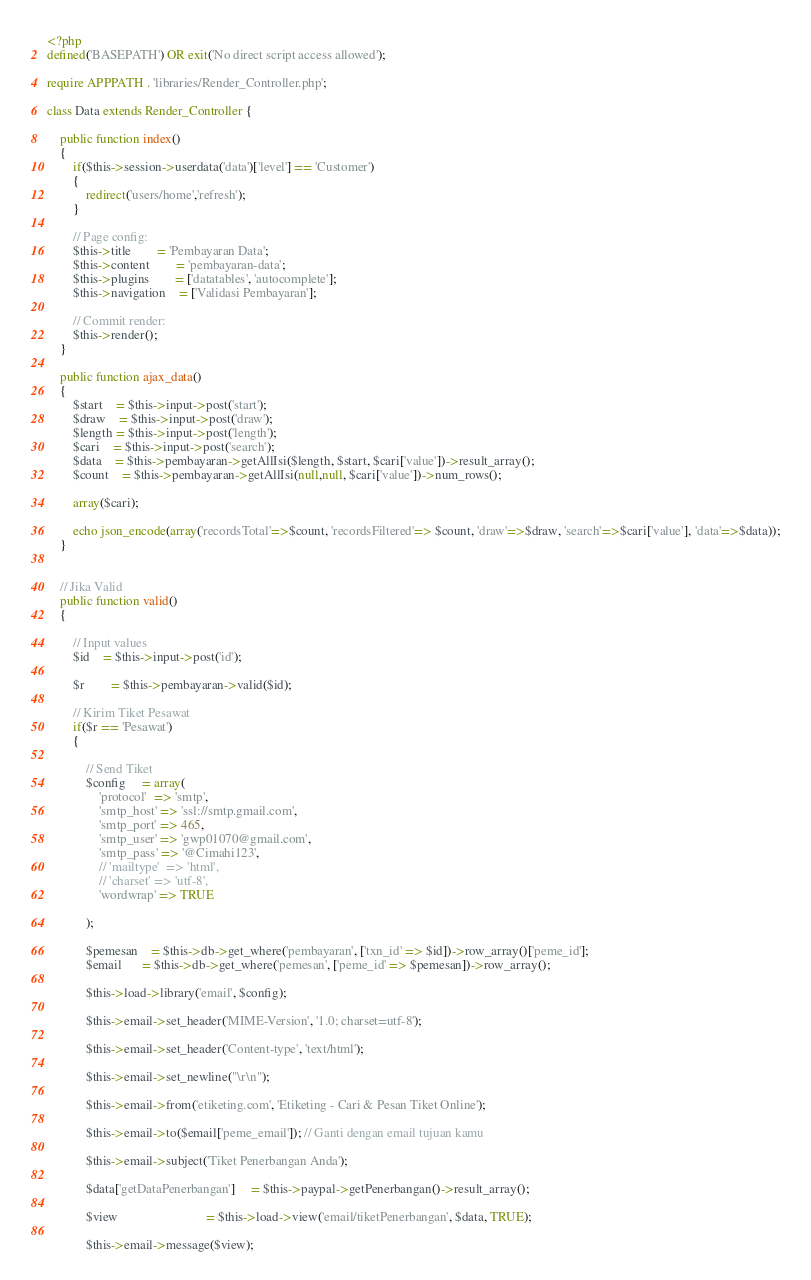Convert code to text. <code><loc_0><loc_0><loc_500><loc_500><_PHP_><?php
defined('BASEPATH') OR exit('No direct script access allowed');

require APPPATH . 'libraries/Render_Controller.php';

class Data extends Render_Controller {

	public function index() 
	{
		if($this->session->userdata('data')['level'] == 'Customer')
		{
			redirect('users/home','refresh');
		}

		// Page config:
		$this->title 		= 'Pembayaran Data';
		$this->content 		= 'pembayaran-data'; 
		$this->plugins 		= ['datatables', 'autocomplete'];
		$this->navigation 	= ['Validasi Pembayaran'];

		// Commit render:
		$this->render();
	}

	public function ajax_data()
	{
		$start 	= $this->input->post('start');
		$draw 	= $this->input->post('draw');
		$length = $this->input->post('length');
		$cari 	= $this->input->post('search');
		$data 	= $this->pembayaran->getAllIsi($length, $start, $cari['value'])->result_array();
		$count 	= $this->pembayaran->getAllIsi(null,null, $cari['value'])->num_rows();
		
		array($cari);

		echo json_encode(array('recordsTotal'=>$count, 'recordsFiltered'=> $count, 'draw'=>$draw, 'search'=>$cari['value'], 'data'=>$data));
	}


	// Jika Valid
	public function valid() 
	{

		// Input values
		$id 	= $this->input->post('id');

		$r 		= $this->pembayaran->valid($id);

		// Kirim Tiket Pesawat
		if($r == 'Pesawat')
		{

			// Send Tiket
	        $config     = array(
	            'protocol'  => 'smtp',
	            'smtp_host' => 'ssl://smtp.gmail.com',
	            'smtp_port' => 465,
	            'smtp_user' => 'gwp01070@gmail.com',
	            'smtp_pass' => '@Cimahi123',
	            // 'mailtype'  => 'html', 
	            // 'charset' => 'utf-8',
	            'wordwrap' => TRUE

	        );

	        $pemesan    = $this->db->get_where('pembayaran', ['txn_id' => $id])->row_array()['peme_id'];
	        $email      = $this->db->get_where('pemesan', ['peme_id' => $pemesan])->row_array();

	        $this->load->library('email', $config);
	        
	        $this->email->set_header('MIME-Version', '1.0; charset=utf-8');
	        
	        $this->email->set_header('Content-type', 'text/html');

	        $this->email->set_newline("\r\n");

	        $this->email->from('etiketing.com', 'Etiketing - Cari & Pesan Tiket Online');

	        $this->email->to($email['peme_email']); // Ganti dengan email tujuan kamu

	        $this->email->subject('Tiket Penerbangan Anda');

	        $data['getDataPenerbangan']     = $this->paypal->getPenerbangan()->result_array();

	        $view                           = $this->load->view('email/tiketPenerbangan', $data, TRUE);

	        $this->email->message($view);
</code> 